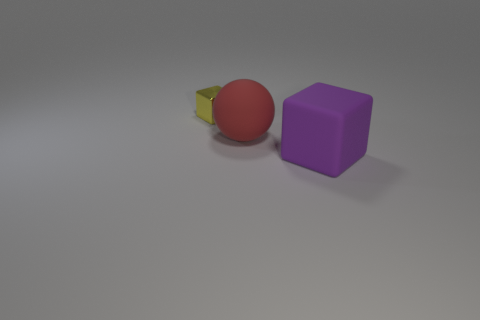Are there any other things that have the same size as the yellow shiny object?
Offer a very short reply. No. Is there anything else that is made of the same material as the yellow block?
Offer a terse response. No. Does the thing in front of the large matte sphere have the same color as the block left of the red rubber ball?
Your response must be concise. No. There is a purple thing that is the same size as the red ball; what is its shape?
Your answer should be compact. Cube. Are there any other small shiny objects of the same shape as the purple thing?
Offer a very short reply. Yes. Does the object in front of the large red matte sphere have the same material as the cube behind the ball?
Ensure brevity in your answer.  No. What number of red spheres are the same material as the large cube?
Ensure brevity in your answer.  1. What is the color of the large ball?
Provide a short and direct response. Red. Is the shape of the large matte object that is in front of the red sphere the same as the big thing behind the big cube?
Your response must be concise. No. What color is the block that is right of the small yellow block?
Make the answer very short. Purple. 